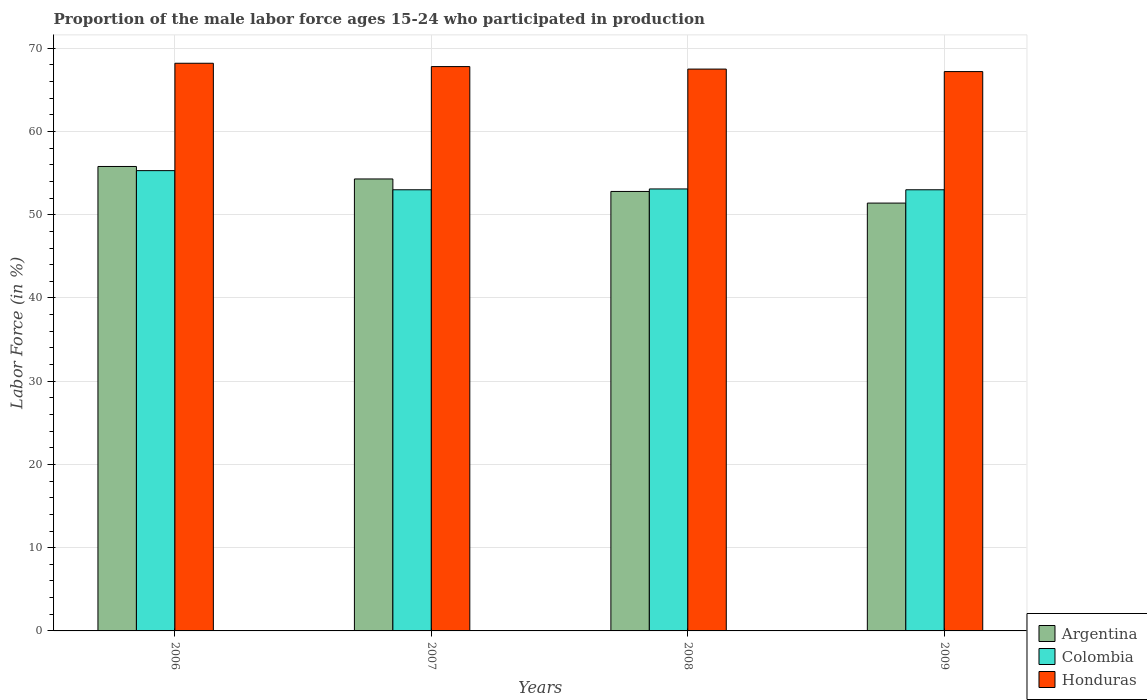How many groups of bars are there?
Offer a very short reply. 4. Are the number of bars on each tick of the X-axis equal?
Offer a terse response. Yes. How many bars are there on the 2nd tick from the right?
Make the answer very short. 3. What is the label of the 1st group of bars from the left?
Your response must be concise. 2006. What is the proportion of the male labor force who participated in production in Honduras in 2008?
Keep it short and to the point. 67.5. Across all years, what is the maximum proportion of the male labor force who participated in production in Argentina?
Make the answer very short. 55.8. Across all years, what is the minimum proportion of the male labor force who participated in production in Argentina?
Provide a succinct answer. 51.4. In which year was the proportion of the male labor force who participated in production in Colombia minimum?
Your answer should be compact. 2007. What is the total proportion of the male labor force who participated in production in Colombia in the graph?
Give a very brief answer. 214.4. What is the difference between the proportion of the male labor force who participated in production in Argentina in 2007 and that in 2008?
Offer a terse response. 1.5. What is the difference between the proportion of the male labor force who participated in production in Argentina in 2007 and the proportion of the male labor force who participated in production in Colombia in 2006?
Provide a succinct answer. -1. What is the average proportion of the male labor force who participated in production in Argentina per year?
Your answer should be compact. 53.57. In the year 2009, what is the difference between the proportion of the male labor force who participated in production in Honduras and proportion of the male labor force who participated in production in Argentina?
Give a very brief answer. 15.8. What is the ratio of the proportion of the male labor force who participated in production in Argentina in 2006 to that in 2007?
Provide a short and direct response. 1.03. Is the proportion of the male labor force who participated in production in Argentina in 2006 less than that in 2009?
Ensure brevity in your answer.  No. Is the difference between the proportion of the male labor force who participated in production in Honduras in 2006 and 2008 greater than the difference between the proportion of the male labor force who participated in production in Argentina in 2006 and 2008?
Keep it short and to the point. No. What is the difference between the highest and the lowest proportion of the male labor force who participated in production in Colombia?
Your answer should be compact. 2.3. In how many years, is the proportion of the male labor force who participated in production in Honduras greater than the average proportion of the male labor force who participated in production in Honduras taken over all years?
Provide a succinct answer. 2. Is the sum of the proportion of the male labor force who participated in production in Colombia in 2008 and 2009 greater than the maximum proportion of the male labor force who participated in production in Argentina across all years?
Your answer should be very brief. Yes. What does the 3rd bar from the left in 2009 represents?
Your response must be concise. Honduras. What does the 1st bar from the right in 2007 represents?
Offer a very short reply. Honduras. Is it the case that in every year, the sum of the proportion of the male labor force who participated in production in Honduras and proportion of the male labor force who participated in production in Argentina is greater than the proportion of the male labor force who participated in production in Colombia?
Provide a succinct answer. Yes. How many bars are there?
Your response must be concise. 12. Are all the bars in the graph horizontal?
Provide a succinct answer. No. Are the values on the major ticks of Y-axis written in scientific E-notation?
Your answer should be very brief. No. Does the graph contain any zero values?
Your response must be concise. No. Where does the legend appear in the graph?
Your response must be concise. Bottom right. What is the title of the graph?
Offer a very short reply. Proportion of the male labor force ages 15-24 who participated in production. What is the Labor Force (in %) of Argentina in 2006?
Make the answer very short. 55.8. What is the Labor Force (in %) in Colombia in 2006?
Keep it short and to the point. 55.3. What is the Labor Force (in %) in Honduras in 2006?
Provide a succinct answer. 68.2. What is the Labor Force (in %) of Argentina in 2007?
Offer a terse response. 54.3. What is the Labor Force (in %) in Honduras in 2007?
Give a very brief answer. 67.8. What is the Labor Force (in %) of Argentina in 2008?
Your answer should be compact. 52.8. What is the Labor Force (in %) of Colombia in 2008?
Offer a terse response. 53.1. What is the Labor Force (in %) in Honduras in 2008?
Keep it short and to the point. 67.5. What is the Labor Force (in %) in Argentina in 2009?
Keep it short and to the point. 51.4. What is the Labor Force (in %) of Honduras in 2009?
Provide a succinct answer. 67.2. Across all years, what is the maximum Labor Force (in %) of Argentina?
Offer a terse response. 55.8. Across all years, what is the maximum Labor Force (in %) of Colombia?
Keep it short and to the point. 55.3. Across all years, what is the maximum Labor Force (in %) in Honduras?
Offer a terse response. 68.2. Across all years, what is the minimum Labor Force (in %) in Argentina?
Keep it short and to the point. 51.4. Across all years, what is the minimum Labor Force (in %) in Colombia?
Keep it short and to the point. 53. Across all years, what is the minimum Labor Force (in %) in Honduras?
Your response must be concise. 67.2. What is the total Labor Force (in %) of Argentina in the graph?
Your answer should be very brief. 214.3. What is the total Labor Force (in %) in Colombia in the graph?
Your response must be concise. 214.4. What is the total Labor Force (in %) of Honduras in the graph?
Your answer should be compact. 270.7. What is the difference between the Labor Force (in %) in Argentina in 2006 and that in 2007?
Offer a terse response. 1.5. What is the difference between the Labor Force (in %) in Colombia in 2006 and that in 2007?
Offer a terse response. 2.3. What is the difference between the Labor Force (in %) in Honduras in 2006 and that in 2007?
Your answer should be compact. 0.4. What is the difference between the Labor Force (in %) of Colombia in 2006 and that in 2008?
Make the answer very short. 2.2. What is the difference between the Labor Force (in %) in Argentina in 2006 and that in 2009?
Your answer should be compact. 4.4. What is the difference between the Labor Force (in %) in Argentina in 2007 and that in 2009?
Provide a succinct answer. 2.9. What is the difference between the Labor Force (in %) of Honduras in 2007 and that in 2009?
Keep it short and to the point. 0.6. What is the difference between the Labor Force (in %) of Honduras in 2008 and that in 2009?
Ensure brevity in your answer.  0.3. What is the difference between the Labor Force (in %) in Argentina in 2006 and the Labor Force (in %) in Colombia in 2007?
Offer a very short reply. 2.8. What is the difference between the Labor Force (in %) in Argentina in 2006 and the Labor Force (in %) in Honduras in 2009?
Give a very brief answer. -11.4. What is the difference between the Labor Force (in %) in Colombia in 2006 and the Labor Force (in %) in Honduras in 2009?
Provide a succinct answer. -11.9. What is the difference between the Labor Force (in %) of Argentina in 2007 and the Labor Force (in %) of Colombia in 2008?
Provide a succinct answer. 1.2. What is the difference between the Labor Force (in %) in Argentina in 2007 and the Labor Force (in %) in Honduras in 2008?
Your response must be concise. -13.2. What is the difference between the Labor Force (in %) in Argentina in 2007 and the Labor Force (in %) in Colombia in 2009?
Keep it short and to the point. 1.3. What is the difference between the Labor Force (in %) in Argentina in 2007 and the Labor Force (in %) in Honduras in 2009?
Your answer should be compact. -12.9. What is the difference between the Labor Force (in %) in Colombia in 2007 and the Labor Force (in %) in Honduras in 2009?
Your answer should be compact. -14.2. What is the difference between the Labor Force (in %) in Argentina in 2008 and the Labor Force (in %) in Honduras in 2009?
Offer a very short reply. -14.4. What is the difference between the Labor Force (in %) of Colombia in 2008 and the Labor Force (in %) of Honduras in 2009?
Make the answer very short. -14.1. What is the average Labor Force (in %) in Argentina per year?
Your response must be concise. 53.58. What is the average Labor Force (in %) in Colombia per year?
Your response must be concise. 53.6. What is the average Labor Force (in %) in Honduras per year?
Ensure brevity in your answer.  67.67. In the year 2006, what is the difference between the Labor Force (in %) in Argentina and Labor Force (in %) in Colombia?
Make the answer very short. 0.5. In the year 2006, what is the difference between the Labor Force (in %) in Colombia and Labor Force (in %) in Honduras?
Ensure brevity in your answer.  -12.9. In the year 2007, what is the difference between the Labor Force (in %) of Argentina and Labor Force (in %) of Colombia?
Ensure brevity in your answer.  1.3. In the year 2007, what is the difference between the Labor Force (in %) of Argentina and Labor Force (in %) of Honduras?
Offer a terse response. -13.5. In the year 2007, what is the difference between the Labor Force (in %) in Colombia and Labor Force (in %) in Honduras?
Give a very brief answer. -14.8. In the year 2008, what is the difference between the Labor Force (in %) of Argentina and Labor Force (in %) of Colombia?
Give a very brief answer. -0.3. In the year 2008, what is the difference between the Labor Force (in %) of Argentina and Labor Force (in %) of Honduras?
Make the answer very short. -14.7. In the year 2008, what is the difference between the Labor Force (in %) of Colombia and Labor Force (in %) of Honduras?
Provide a succinct answer. -14.4. In the year 2009, what is the difference between the Labor Force (in %) in Argentina and Labor Force (in %) in Colombia?
Give a very brief answer. -1.6. In the year 2009, what is the difference between the Labor Force (in %) of Argentina and Labor Force (in %) of Honduras?
Your answer should be compact. -15.8. In the year 2009, what is the difference between the Labor Force (in %) of Colombia and Labor Force (in %) of Honduras?
Offer a very short reply. -14.2. What is the ratio of the Labor Force (in %) in Argentina in 2006 to that in 2007?
Your answer should be compact. 1.03. What is the ratio of the Labor Force (in %) of Colombia in 2006 to that in 2007?
Your response must be concise. 1.04. What is the ratio of the Labor Force (in %) of Honduras in 2006 to that in 2007?
Provide a short and direct response. 1.01. What is the ratio of the Labor Force (in %) of Argentina in 2006 to that in 2008?
Give a very brief answer. 1.06. What is the ratio of the Labor Force (in %) in Colombia in 2006 to that in 2008?
Offer a very short reply. 1.04. What is the ratio of the Labor Force (in %) of Honduras in 2006 to that in 2008?
Offer a terse response. 1.01. What is the ratio of the Labor Force (in %) of Argentina in 2006 to that in 2009?
Offer a terse response. 1.09. What is the ratio of the Labor Force (in %) of Colombia in 2006 to that in 2009?
Keep it short and to the point. 1.04. What is the ratio of the Labor Force (in %) of Honduras in 2006 to that in 2009?
Your response must be concise. 1.01. What is the ratio of the Labor Force (in %) of Argentina in 2007 to that in 2008?
Give a very brief answer. 1.03. What is the ratio of the Labor Force (in %) in Argentina in 2007 to that in 2009?
Your answer should be very brief. 1.06. What is the ratio of the Labor Force (in %) of Colombia in 2007 to that in 2009?
Offer a very short reply. 1. What is the ratio of the Labor Force (in %) of Honduras in 2007 to that in 2009?
Keep it short and to the point. 1.01. What is the ratio of the Labor Force (in %) in Argentina in 2008 to that in 2009?
Your response must be concise. 1.03. What is the ratio of the Labor Force (in %) of Colombia in 2008 to that in 2009?
Give a very brief answer. 1. What is the ratio of the Labor Force (in %) of Honduras in 2008 to that in 2009?
Your response must be concise. 1. 